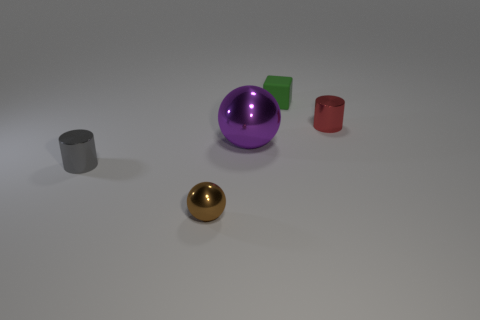Add 2 tiny gray shiny things. How many objects exist? 7 Subtract all cylinders. How many objects are left? 3 Add 3 purple things. How many purple things are left? 4 Add 2 small cubes. How many small cubes exist? 3 Subtract 0 yellow cylinders. How many objects are left? 5 Subtract all tiny red rubber spheres. Subtract all big purple spheres. How many objects are left? 4 